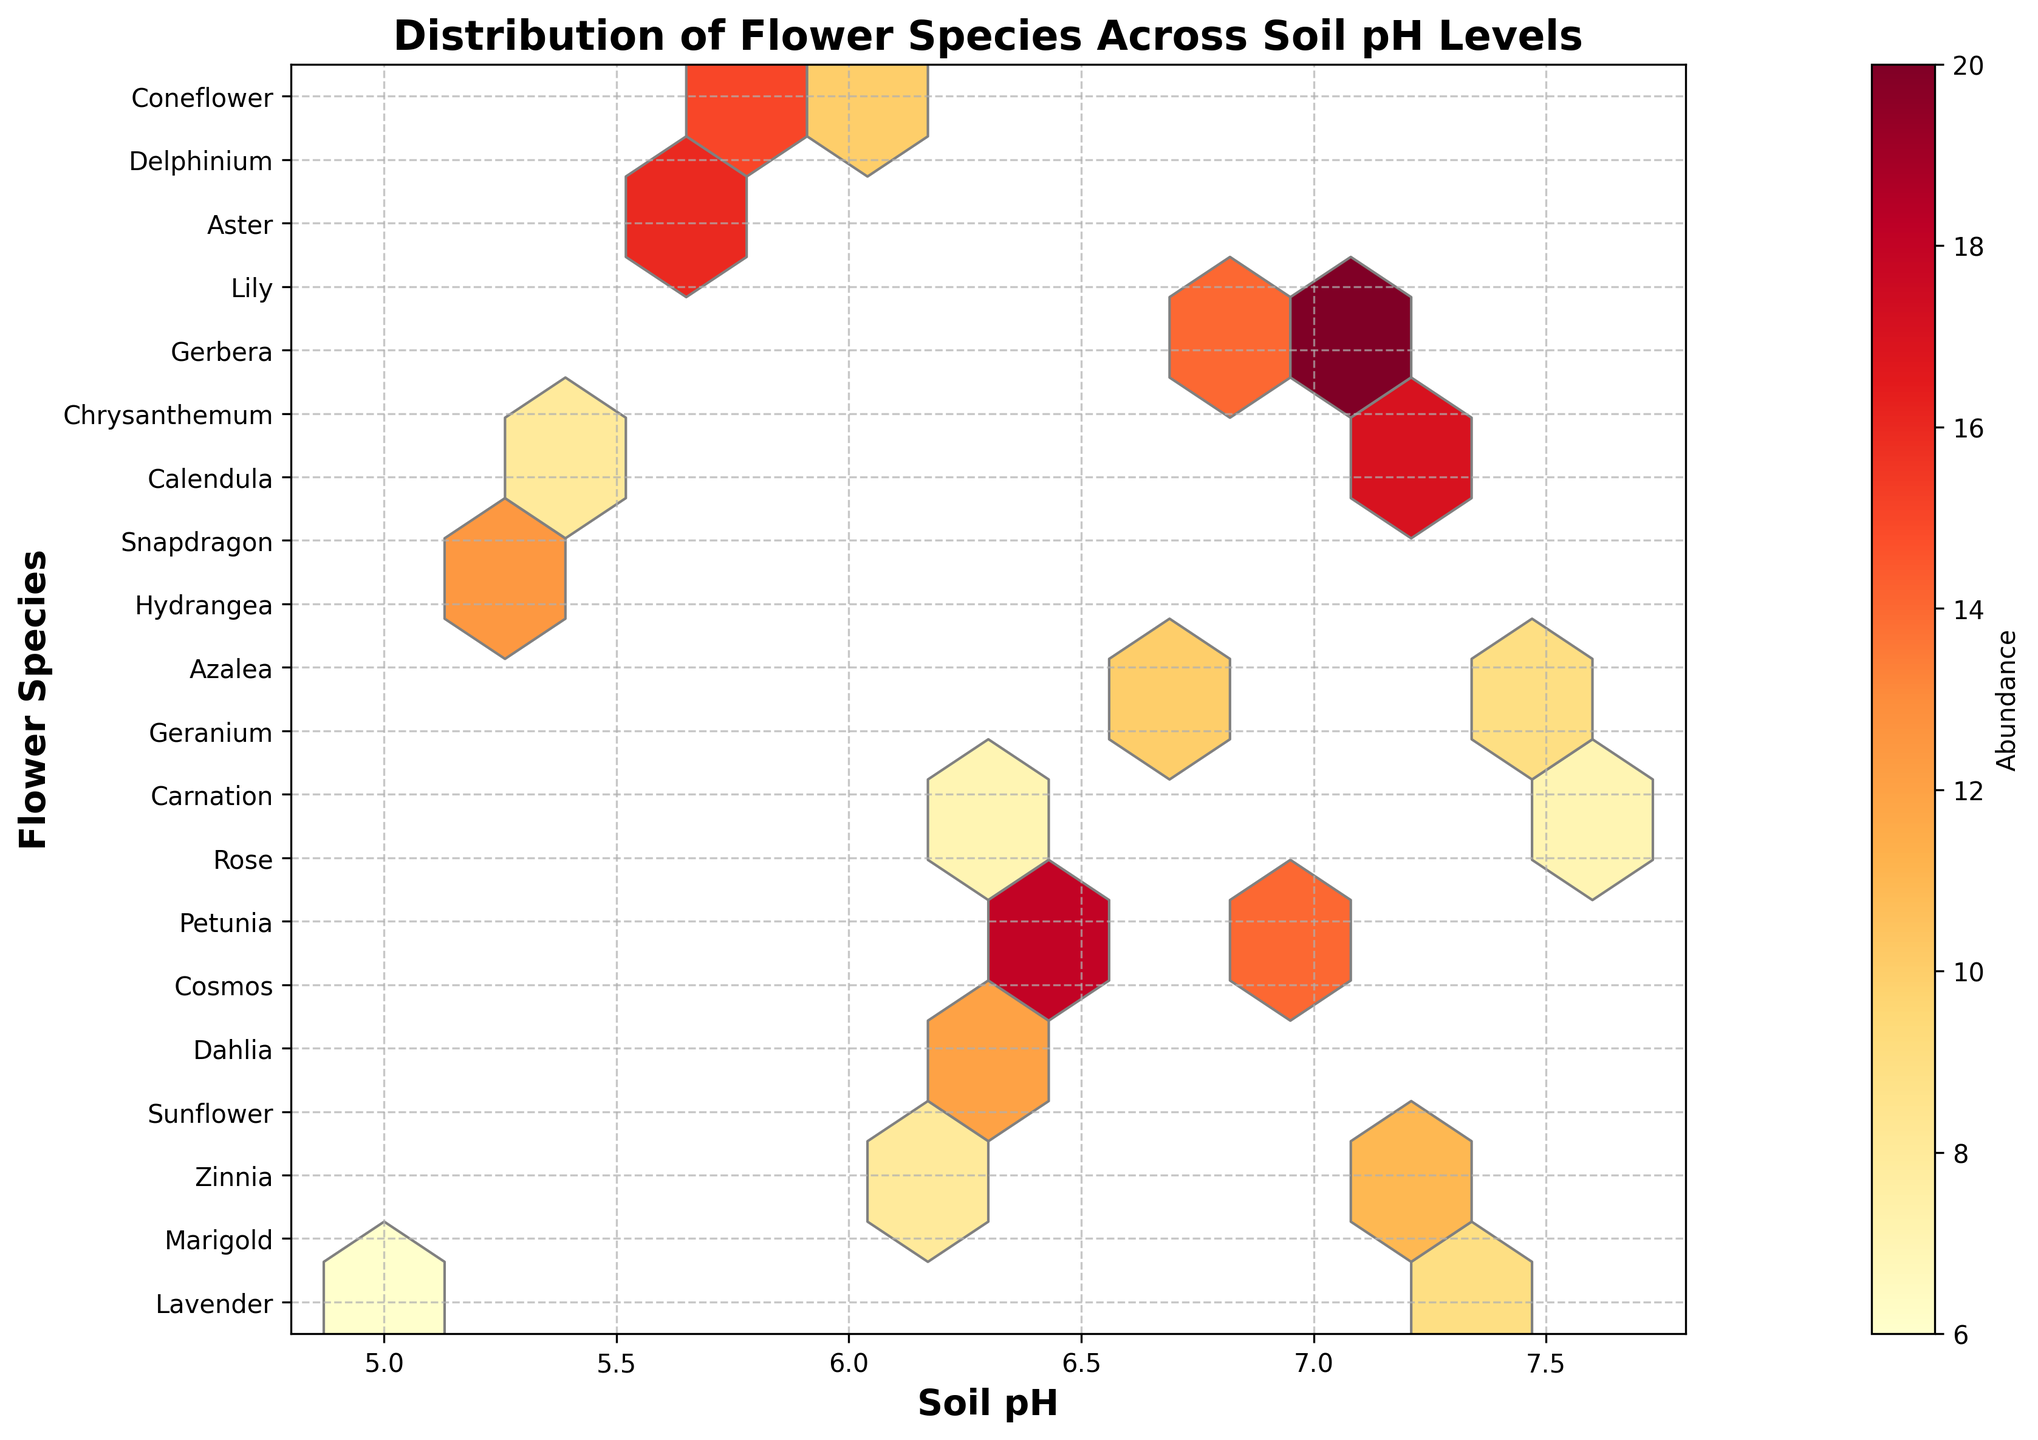How many flower species are represented in the figure? Count the number of unique flower species listed on the y-axis. There should be one tick/label per species.
Answer: 19 What soil pH levels are covered in the plot? Check the range of x-axis values, noting the starting and ending points.
Answer: 5.0 - 7.6 Which flower species has the highest abundance? Look for the hexagon with the highest color intensity and refer to the y-axis to find the corresponding flower species.
Answer: Rose What is the average soil pH for species with more than 10 in abundance? Identify flower species with abundance values greater than 10. Note their soil pH levels and calculate the average. (Soil pH for Lavender, Zinnia, Cosmos, Petunia, Rose, Snapdragon, and Lily are: 5.2, 5.8, 6.5, 6.8, 7.0, 5.7, and 7.1) Sum these up (5.2 + 5.8 + 6.5 + 6.8 + 7.0 + 5.7 + 7.1 = 44.1) and divide by 7 (number of species).
Answer: 6.3 Which soil pH range has the highest overall flower abundance? Sum the abundance within each soil pH range. Compare the sums to determine the highest one.
Answer: 7.0 -7.2 Which flower species appear to thrive best in acidic soil (pH < 6.5)? Identify species that fall in the acidic range and check their abundances: Azalea, Lavender, Hydrangea, Marigold, Zinnia, Snapdragon. Compare their abundances.
Answer: Snapdragon Are there any soil pH levels where multiple flower species have the same abundance? Look for identical colors on different rows but aligned vertically on the same soil pH level.
Answer: No What is the color representing the highest abundance in the plot? Take a look at the color bar scale beside the plot and identify the color corresponding to the highest value.
Answer: Dark Red Which species has the lowest abundance and what is its soil pH? Find the least intense color (lightest) in the plot and check the corresponding species and soil pH.
Answer: Azalea, 5.0 Does any flower species have a consistent abundance across different soil pH levels? Check if any species name appears more than once across different soil pH levels with the same hexagon color shade (indicating similar abundance).
Answer: No 